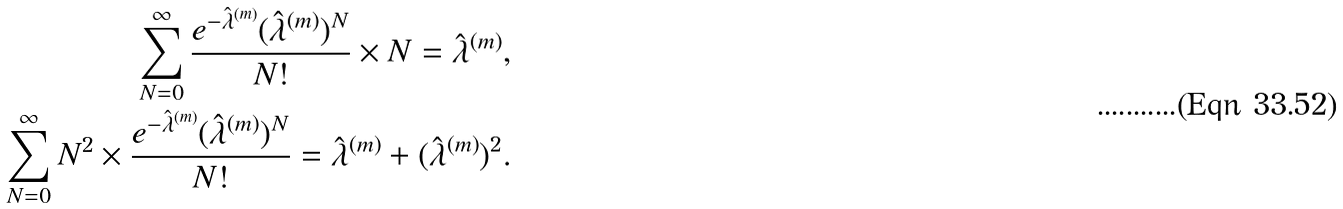Convert formula to latex. <formula><loc_0><loc_0><loc_500><loc_500>\sum _ { N = 0 } ^ { \infty } \frac { e ^ { - { \hat { \lambda } } ^ { ( m ) } } ( \hat { \lambda } ^ { ( m ) } ) ^ { N } } { N ! } \times N = \hat { \lambda } ^ { ( m ) } , \\ \sum _ { N = 0 } ^ { \infty } N ^ { 2 } \times \frac { e ^ { - { \hat { \lambda } } ^ { ( m ) } } ( \hat { \lambda } ^ { ( m ) } ) ^ { N } } { N ! } = \hat { \lambda } ^ { ( m ) } + ( \hat { \lambda } ^ { ( m ) } ) ^ { 2 } .</formula> 